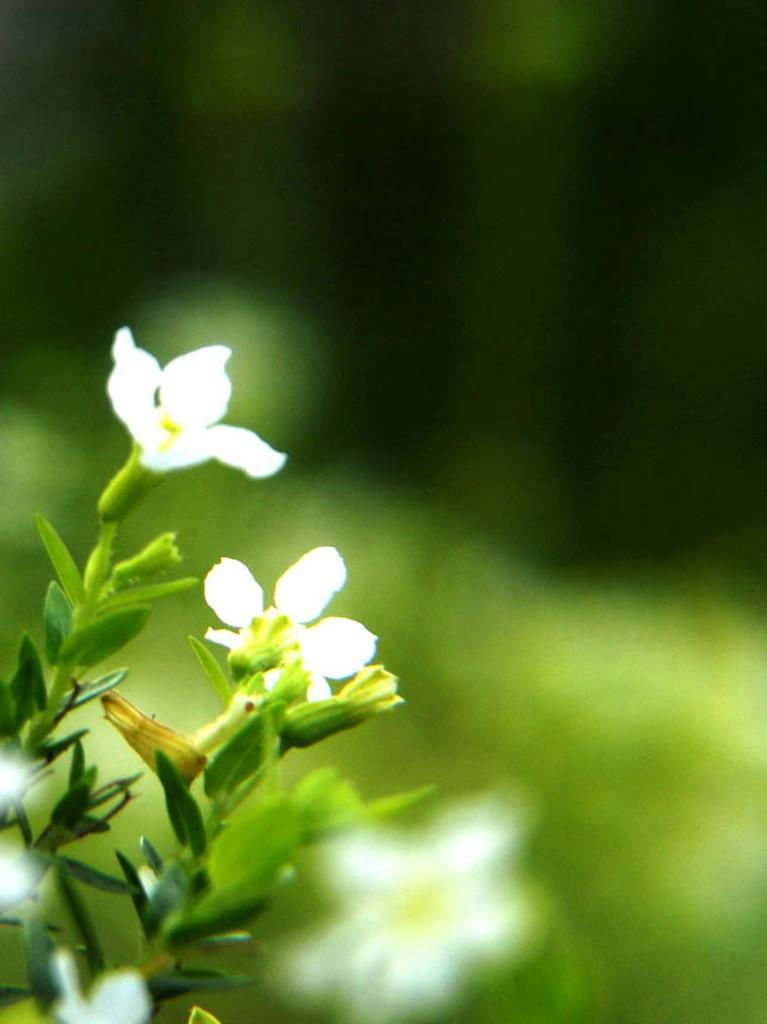How would you summarize this image in a sentence or two? In this picture, on the left side, we can see a plant with some flowers and the flower is in white color. In the background, we can see a green color. 